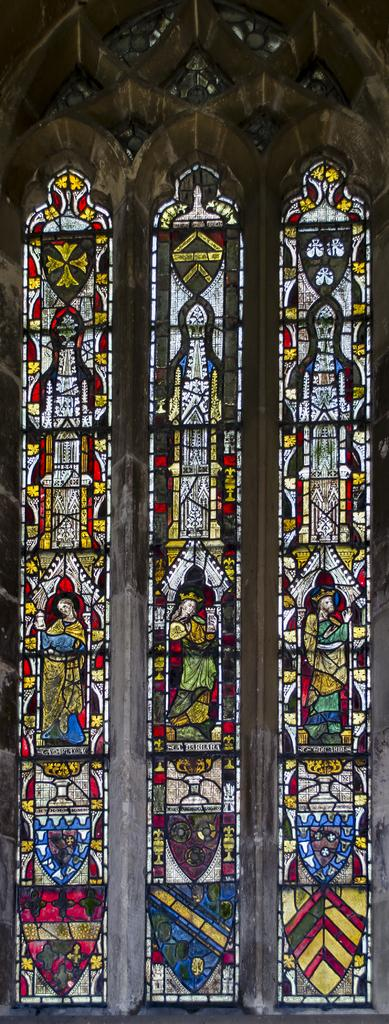What type of decorative element is on the wall in the image? There is a stained glass on the wall in the image. How many passengers are waiting at the airport in the image? There is no airport or passengers present in the image; it only features a stained glass on the wall. 